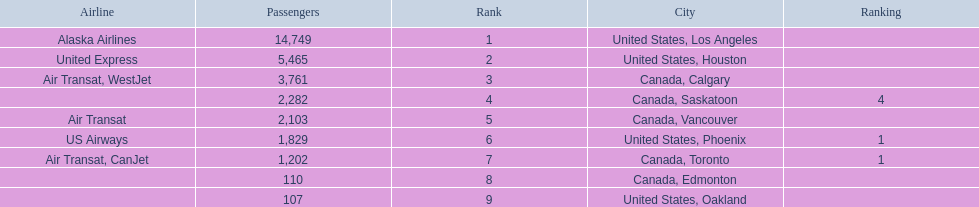What are all the cities? United States, Los Angeles, United States, Houston, Canada, Calgary, Canada, Saskatoon, Canada, Vancouver, United States, Phoenix, Canada, Toronto, Canada, Edmonton, United States, Oakland. How many passengers do they service? 14,749, 5,465, 3,761, 2,282, 2,103, 1,829, 1,202, 110, 107. Which city, when combined with los angeles, totals nearly 19,000? Canada, Calgary. 